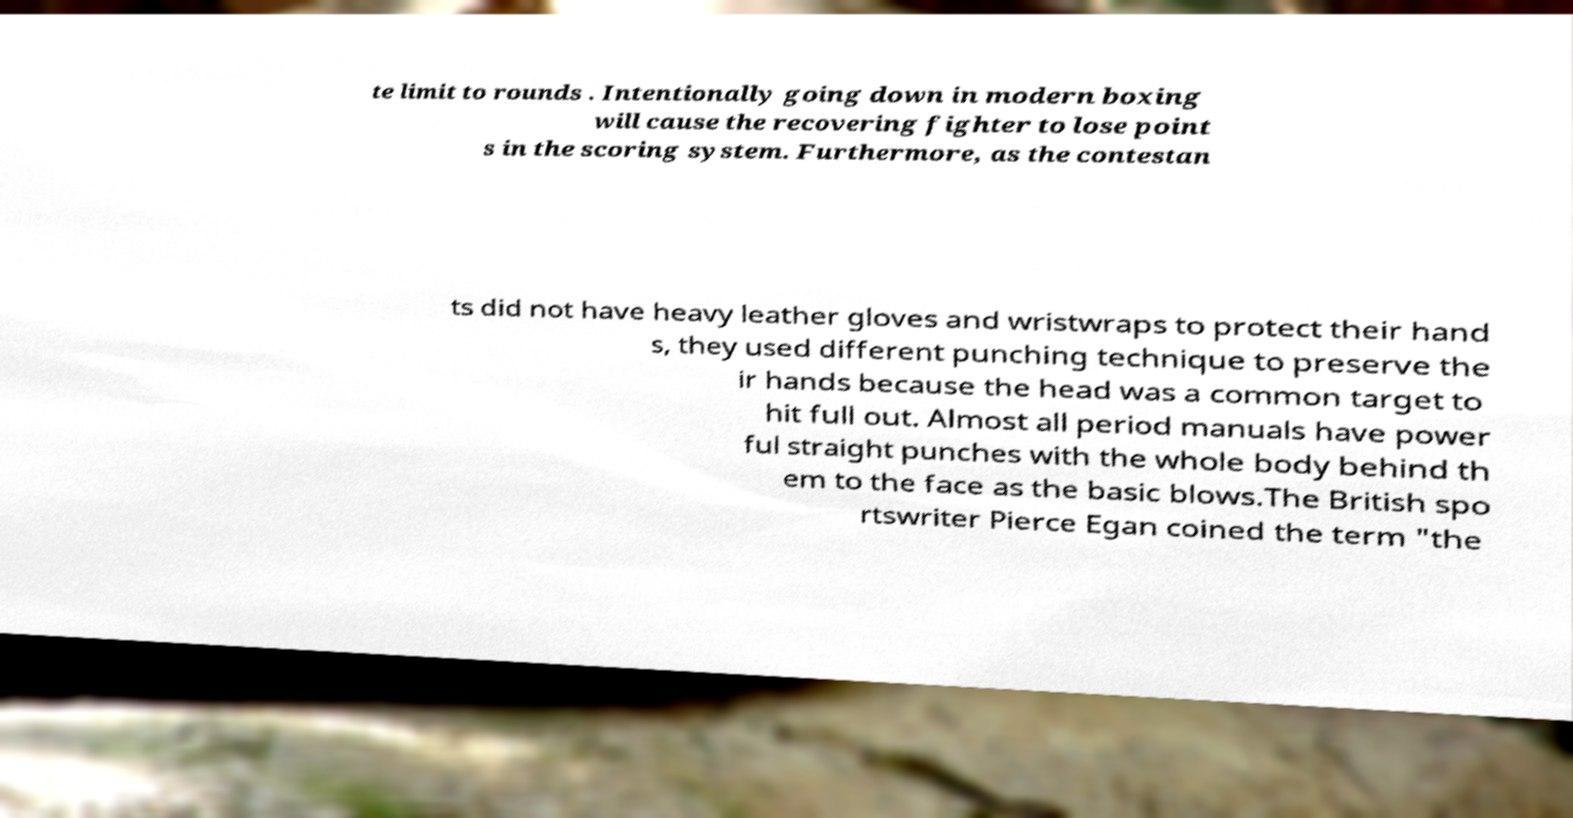I need the written content from this picture converted into text. Can you do that? te limit to rounds . Intentionally going down in modern boxing will cause the recovering fighter to lose point s in the scoring system. Furthermore, as the contestan ts did not have heavy leather gloves and wristwraps to protect their hand s, they used different punching technique to preserve the ir hands because the head was a common target to hit full out. Almost all period manuals have power ful straight punches with the whole body behind th em to the face as the basic blows.The British spo rtswriter Pierce Egan coined the term "the 